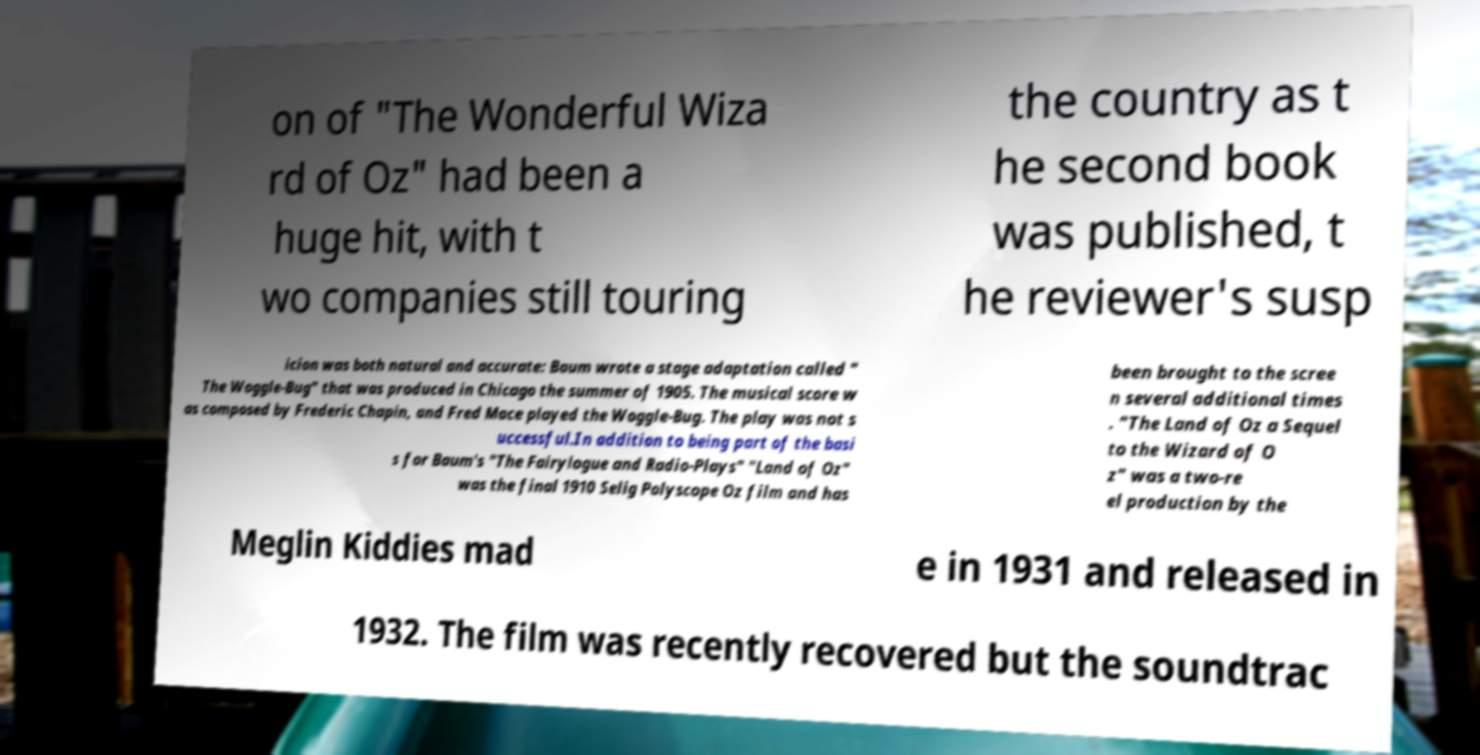Could you assist in decoding the text presented in this image and type it out clearly? on of "The Wonderful Wiza rd of Oz" had been a huge hit, with t wo companies still touring the country as t he second book was published, t he reviewer's susp icion was both natural and accurate: Baum wrote a stage adaptation called " The Woggle-Bug" that was produced in Chicago the summer of 1905. The musical score w as composed by Frederic Chapin, and Fred Mace played the Woggle-Bug. The play was not s uccessful.In addition to being part of the basi s for Baum's "The Fairylogue and Radio-Plays" "Land of Oz" was the final 1910 Selig Polyscope Oz film and has been brought to the scree n several additional times . "The Land of Oz a Sequel to the Wizard of O z" was a two-re el production by the Meglin Kiddies mad e in 1931 and released in 1932. The film was recently recovered but the soundtrac 